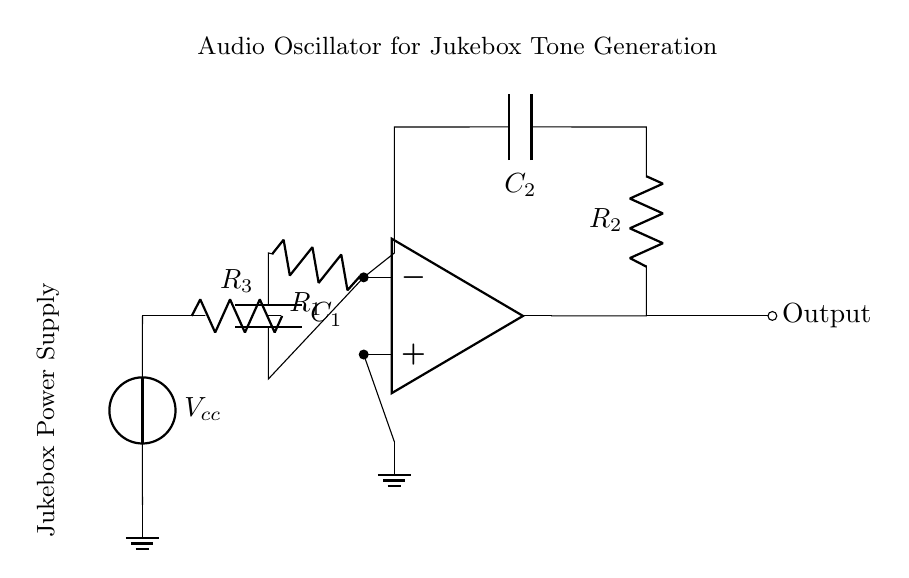What components are used in this audio oscillator circuit? The circuit uses an operational amplifier, two resistors (R1 and R2), two capacitors (C1 and C2), and a power supply (Vcc). Each component is represented in the diagram with specific labels.
Answer: operational amplifier, resistors, capacitors, power supply What is the purpose of the operational amplifier in this circuit? The operational amplifier is used to amplify the signal and oscillate it, creating audio tones needed for jukebox tone generation. It is central to the functionality of the oscillator.
Answer: amplify and oscillate What is the value of R1? The circuit diagram does not specify the numerical values for the components; however, R1 is labeled, indicating its position within the feedback network around the operational amplifier.
Answer: not specified What components are in the feedback loop? The feedback loop consists of R2 and C2 which connect the output of the operational amplifier back to its inverting input, establishing the oscillating conditions necessary for tone generation.
Answer: R2 and C2 How do resistors and capacitors interact in this circuit? Resistors and capacitors form an RC network that determines the frequency of oscillation through their time constant, influencing the output audio tones generated by the oscillator circuit.
Answer: determines frequency What is the function of the power supply labeled Vcc? The power supply Vcc provides the necessary voltage for the operational amplifier to operate and generate the oscillation, crucial for producing audio tones in the circuit.
Answer: provide voltage What type of circuit is represented in this diagram? This circuit is specifically an audio oscillator circuit, used for tone generation in jukeboxes, indicated by the operational amplifier and the configuration of resistors and capacitors.
Answer: audio oscillator circuit 